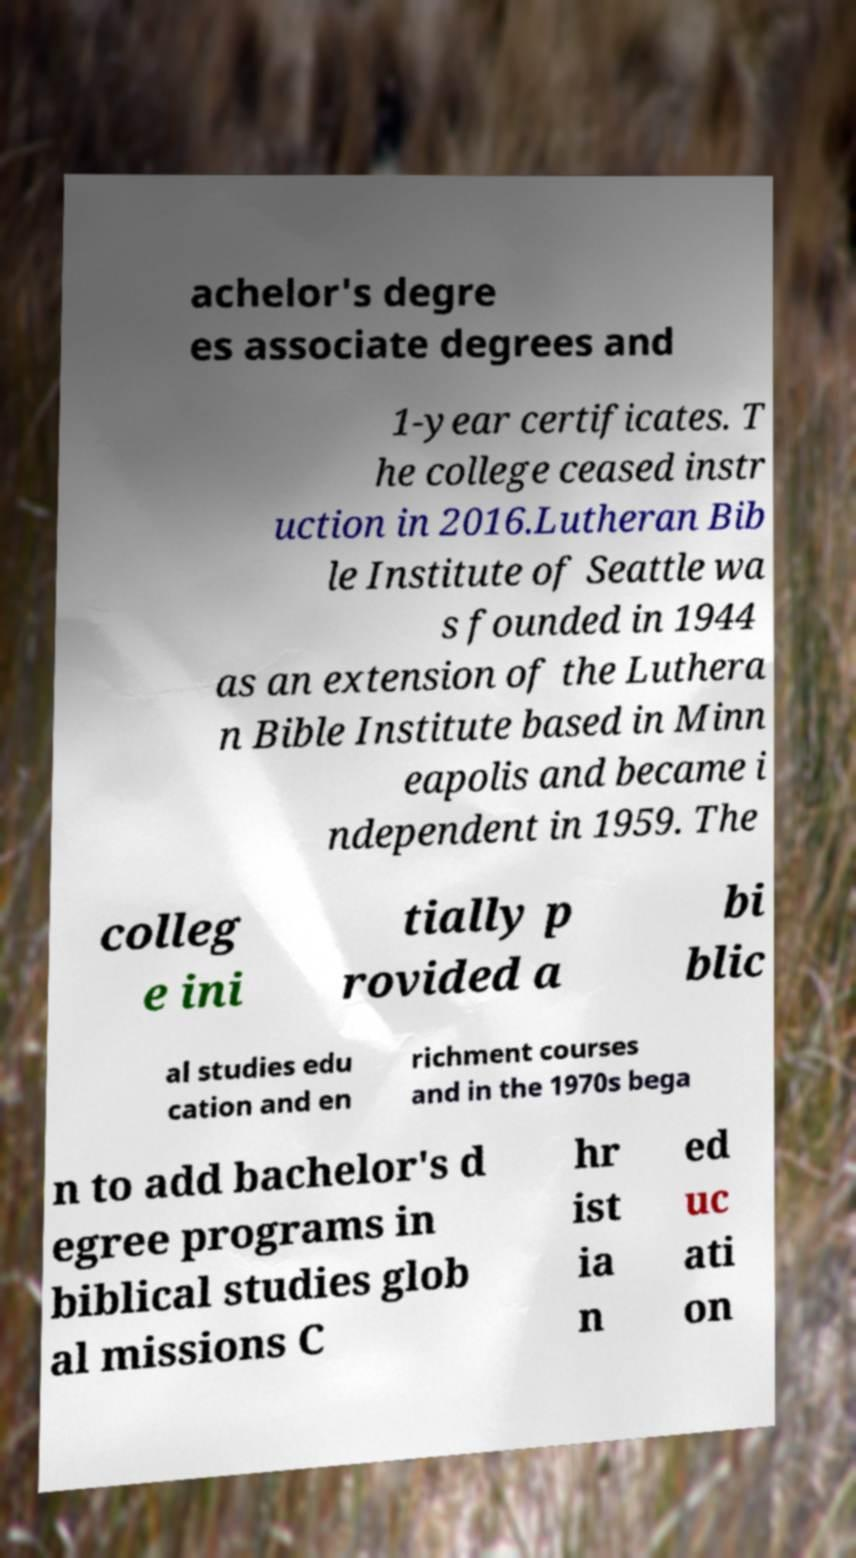What messages or text are displayed in this image? I need them in a readable, typed format. achelor's degre es associate degrees and 1-year certificates. T he college ceased instr uction in 2016.Lutheran Bib le Institute of Seattle wa s founded in 1944 as an extension of the Luthera n Bible Institute based in Minn eapolis and became i ndependent in 1959. The colleg e ini tially p rovided a bi blic al studies edu cation and en richment courses and in the 1970s bega n to add bachelor's d egree programs in biblical studies glob al missions C hr ist ia n ed uc ati on 